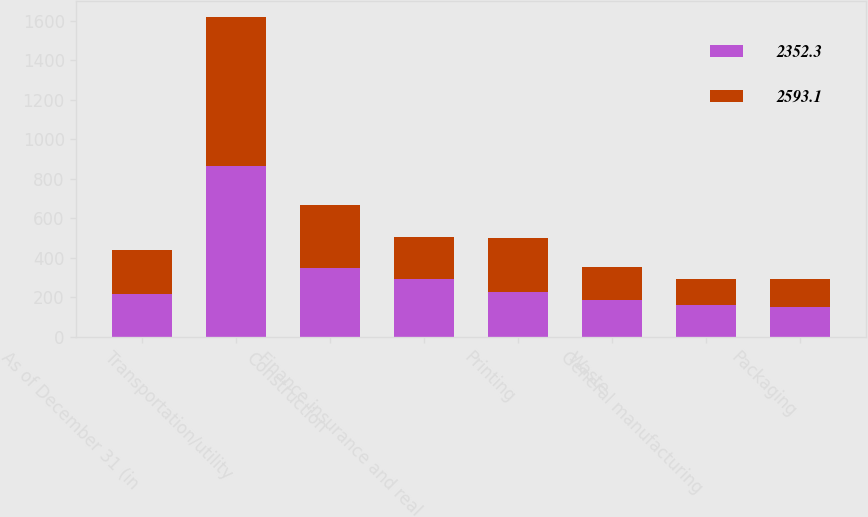<chart> <loc_0><loc_0><loc_500><loc_500><stacked_bar_chart><ecel><fcel>As of December 31 (in<fcel>Transportation/utility<fcel>Construction<fcel>Finance insurance and real<fcel>Printing<fcel>Waste<fcel>General manufacturing<fcel>Packaging<nl><fcel>2352.3<fcel>219.25<fcel>864.5<fcel>348.4<fcel>292.5<fcel>226.4<fcel>187.9<fcel>159.4<fcel>151.2<nl><fcel>2593.1<fcel>219.25<fcel>753.3<fcel>317.1<fcel>212.1<fcel>276.3<fcel>167.2<fcel>132.4<fcel>144.7<nl></chart> 